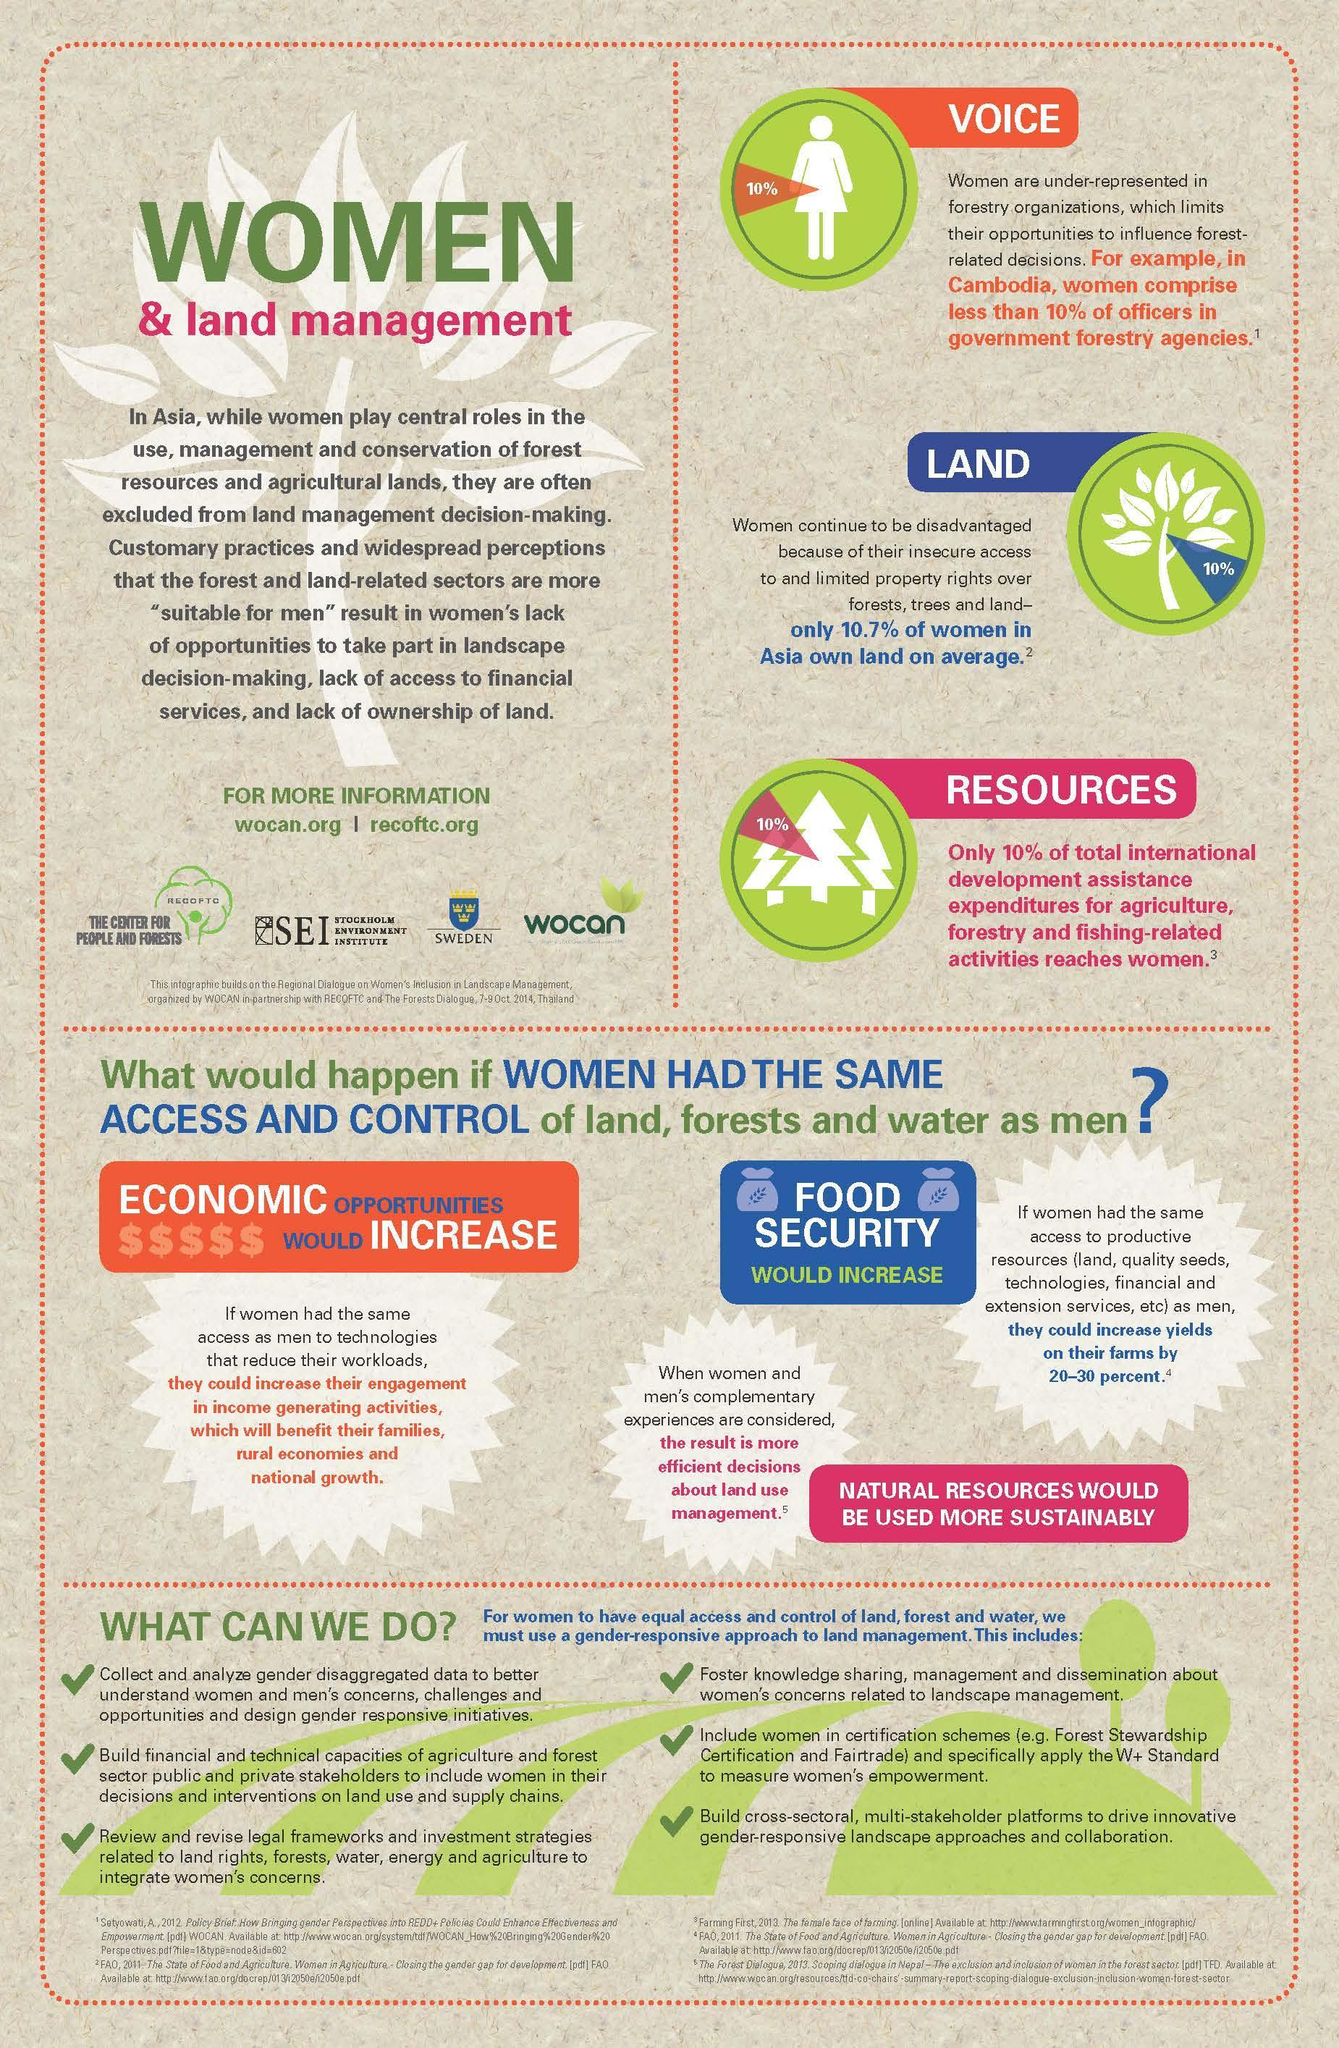What percentage of the Asian Land is owned by men?
Answer the question with a short phrase. 89.3 What percentage of Cambodian forest officers are men? 90 